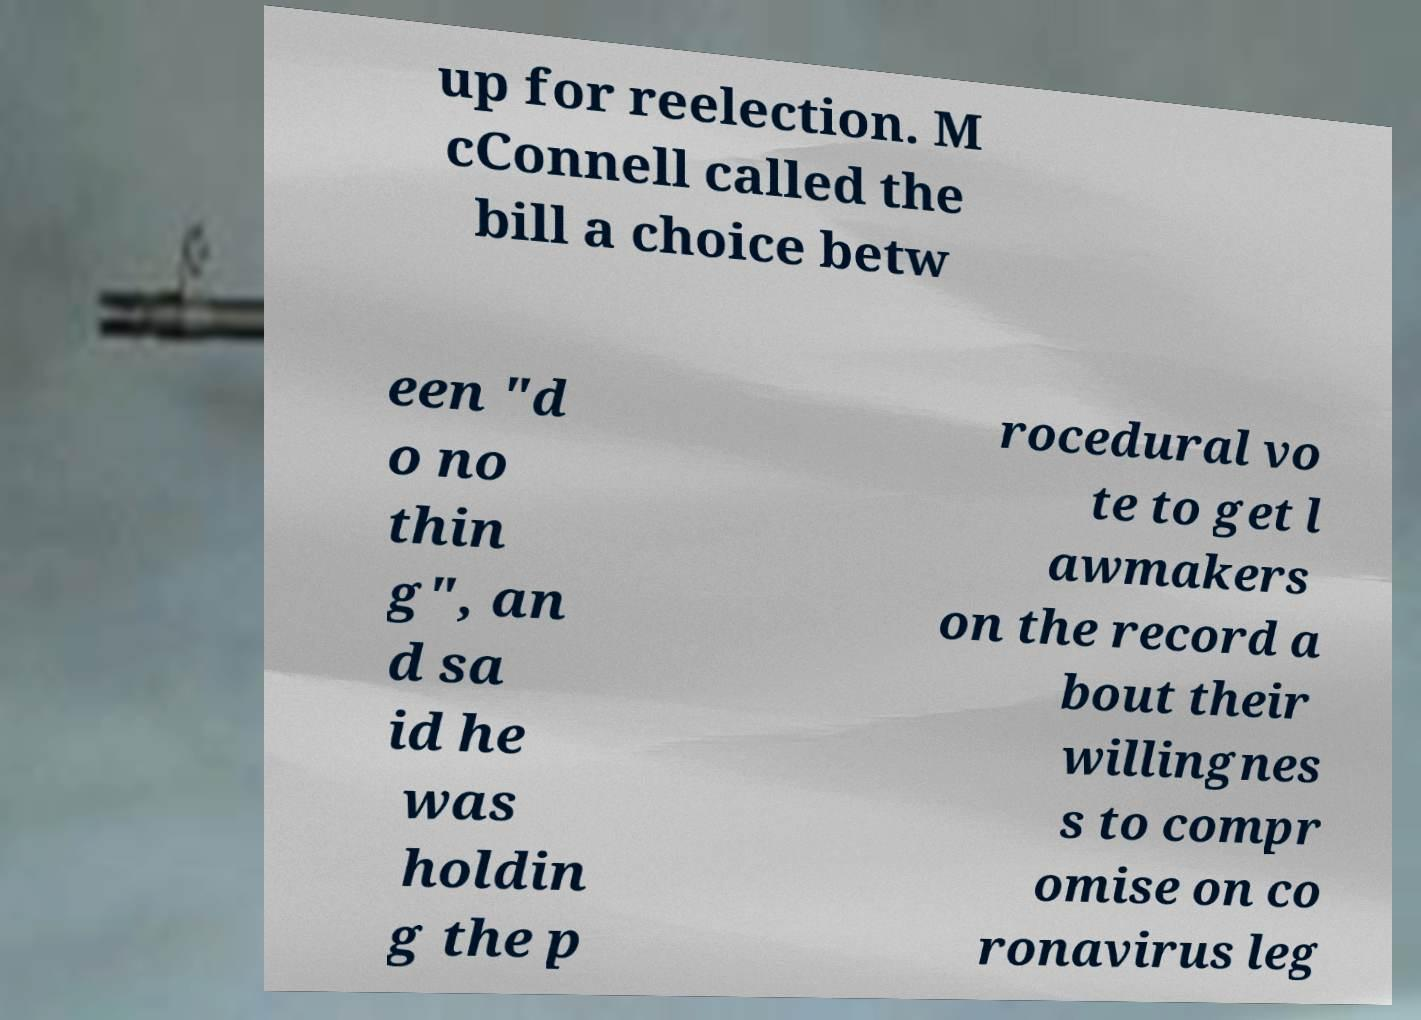There's text embedded in this image that I need extracted. Can you transcribe it verbatim? up for reelection. M cConnell called the bill a choice betw een "d o no thin g", an d sa id he was holdin g the p rocedural vo te to get l awmakers on the record a bout their willingnes s to compr omise on co ronavirus leg 